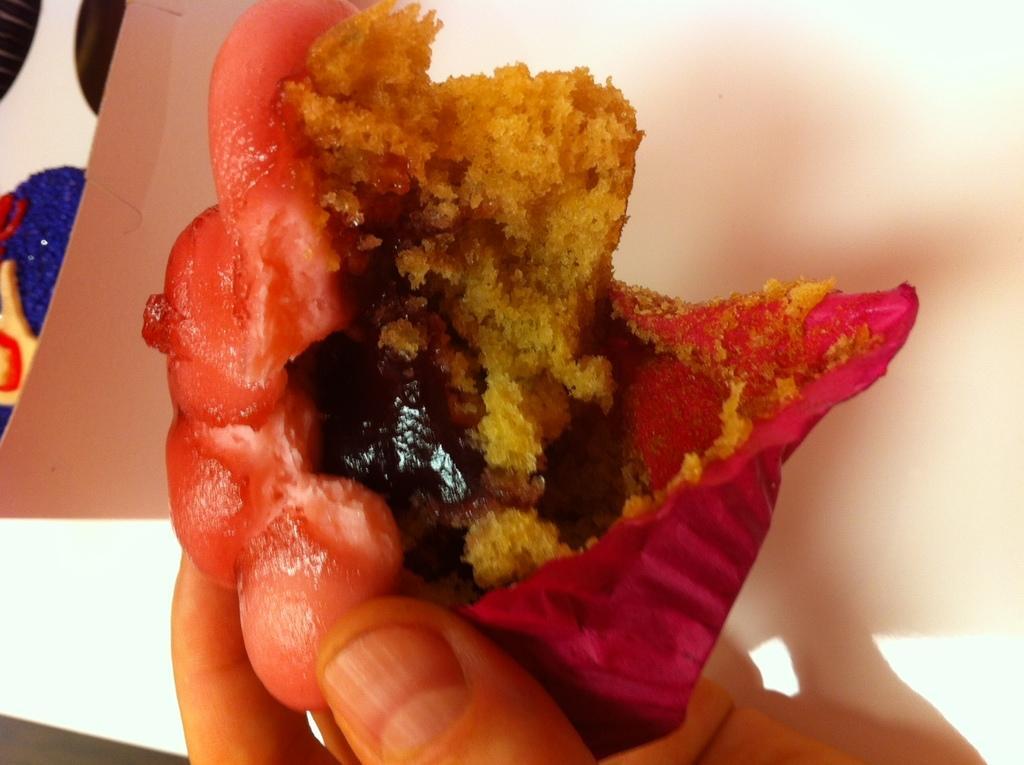Can you describe this image briefly? In the foreground of this image, there is a person´a hand holding a cup cake piece. In the background, there is a cardboard box. 